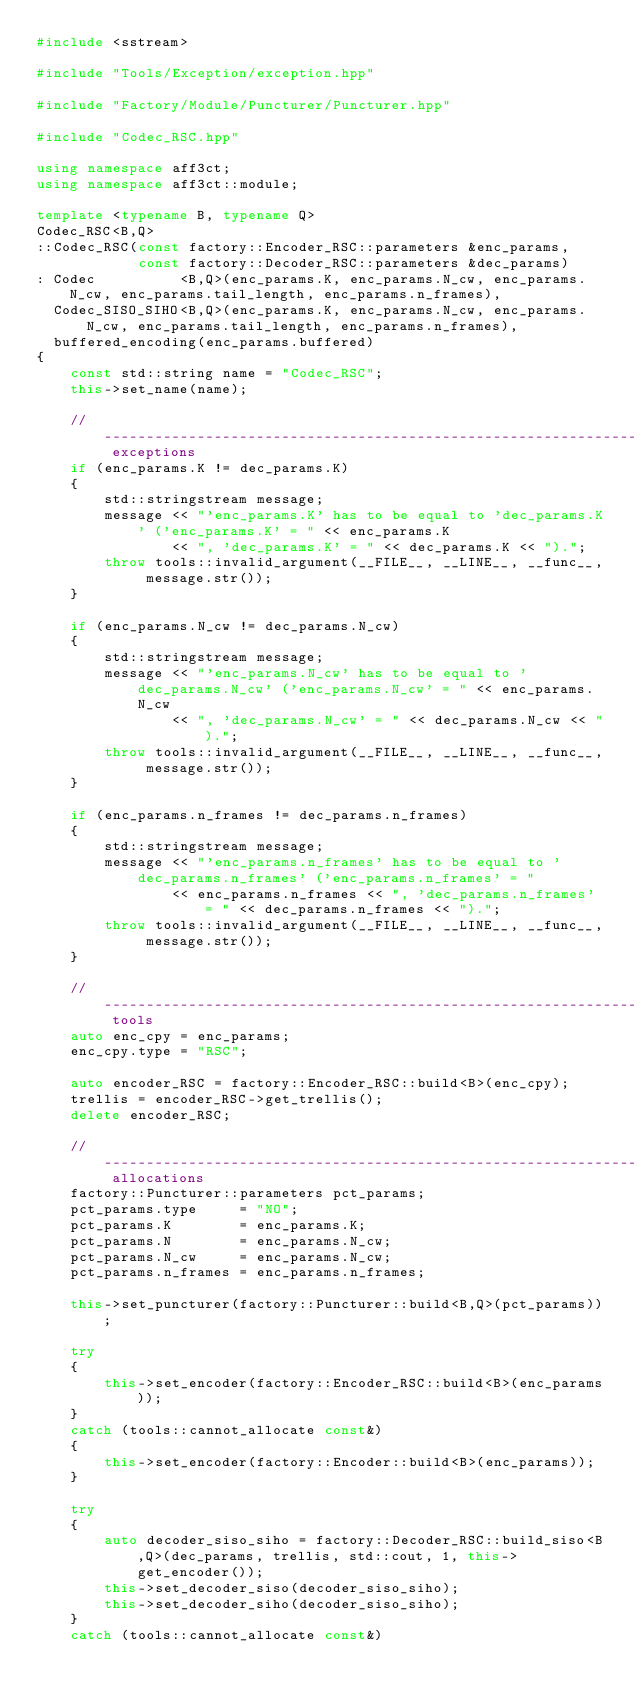<code> <loc_0><loc_0><loc_500><loc_500><_C++_>#include <sstream>

#include "Tools/Exception/exception.hpp"

#include "Factory/Module/Puncturer/Puncturer.hpp"

#include "Codec_RSC.hpp"

using namespace aff3ct;
using namespace aff3ct::module;

template <typename B, typename Q>
Codec_RSC<B,Q>
::Codec_RSC(const factory::Encoder_RSC::parameters &enc_params,
            const factory::Decoder_RSC::parameters &dec_params)
: Codec          <B,Q>(enc_params.K, enc_params.N_cw, enc_params.N_cw, enc_params.tail_length, enc_params.n_frames),
  Codec_SISO_SIHO<B,Q>(enc_params.K, enc_params.N_cw, enc_params.N_cw, enc_params.tail_length, enc_params.n_frames),
  buffered_encoding(enc_params.buffered)
{
	const std::string name = "Codec_RSC";
	this->set_name(name);
	
	// ----------------------------------------------------------------------------------------------------- exceptions
	if (enc_params.K != dec_params.K)
	{
		std::stringstream message;
		message << "'enc_params.K' has to be equal to 'dec_params.K' ('enc_params.K' = " << enc_params.K
		        << ", 'dec_params.K' = " << dec_params.K << ").";
		throw tools::invalid_argument(__FILE__, __LINE__, __func__, message.str());
	}

	if (enc_params.N_cw != dec_params.N_cw)
	{
		std::stringstream message;
		message << "'enc_params.N_cw' has to be equal to 'dec_params.N_cw' ('enc_params.N_cw' = " << enc_params.N_cw
		        << ", 'dec_params.N_cw' = " << dec_params.N_cw << ").";
		throw tools::invalid_argument(__FILE__, __LINE__, __func__, message.str());
	}

	if (enc_params.n_frames != dec_params.n_frames)
	{
		std::stringstream message;
		message << "'enc_params.n_frames' has to be equal to 'dec_params.n_frames' ('enc_params.n_frames' = "
		        << enc_params.n_frames << ", 'dec_params.n_frames' = " << dec_params.n_frames << ").";
		throw tools::invalid_argument(__FILE__, __LINE__, __func__, message.str());
	}

	// ---------------------------------------------------------------------------------------------------------- tools
	auto enc_cpy = enc_params;
	enc_cpy.type = "RSC";

	auto encoder_RSC = factory::Encoder_RSC::build<B>(enc_cpy);
	trellis = encoder_RSC->get_trellis();
	delete encoder_RSC;

	// ---------------------------------------------------------------------------------------------------- allocations
	factory::Puncturer::parameters pct_params;
	pct_params.type     = "NO";
	pct_params.K        = enc_params.K;
	pct_params.N        = enc_params.N_cw;
	pct_params.N_cw     = enc_params.N_cw;
	pct_params.n_frames = enc_params.n_frames;

	this->set_puncturer(factory::Puncturer::build<B,Q>(pct_params));

	try
	{
		this->set_encoder(factory::Encoder_RSC::build<B>(enc_params));
	}
	catch (tools::cannot_allocate const&)
	{
		this->set_encoder(factory::Encoder::build<B>(enc_params));
	}

	try
	{
		auto decoder_siso_siho = factory::Decoder_RSC::build_siso<B,Q>(dec_params, trellis, std::cout, 1, this->get_encoder());
		this->set_decoder_siso(decoder_siso_siho);
		this->set_decoder_siho(decoder_siso_siho);
	}
	catch (tools::cannot_allocate const&)</code> 